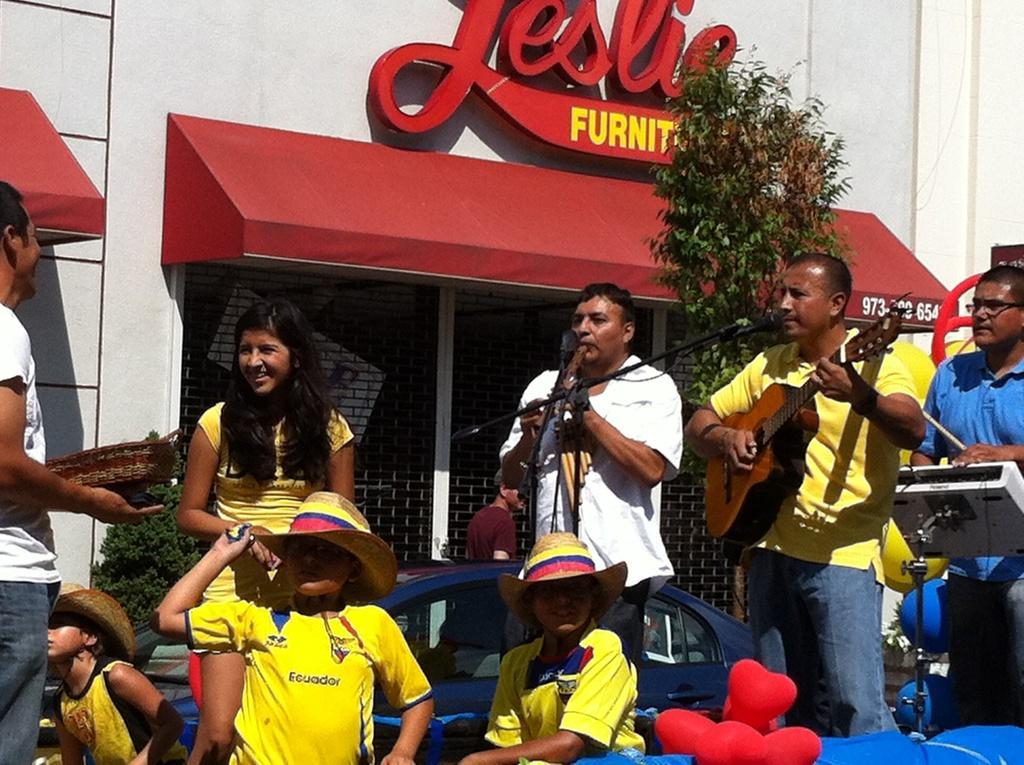In one or two sentences, can you explain what this image depicts? There are few people on the stage performing by playing musical instrument. In front of them there are few people sitting and standing. Behind them there is a building,tree and vehicle. 